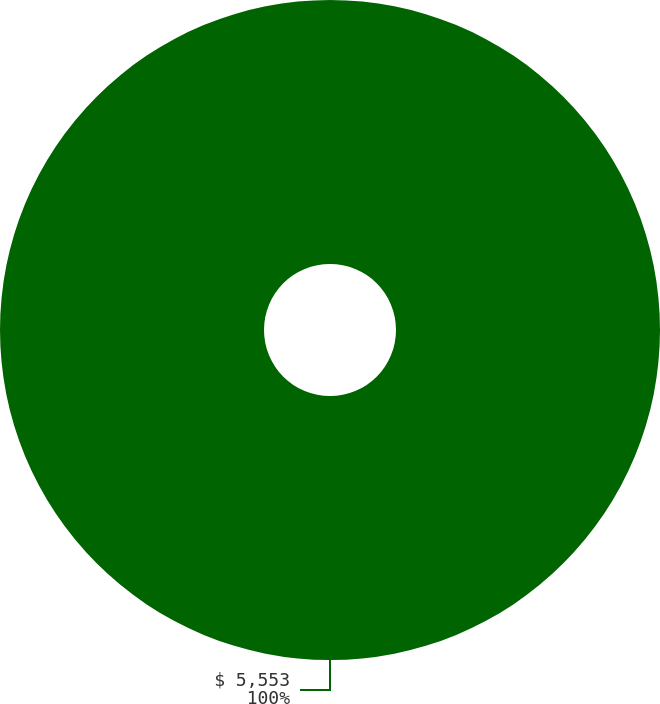Convert chart to OTSL. <chart><loc_0><loc_0><loc_500><loc_500><pie_chart><fcel>$ 5,553<nl><fcel>100.0%<nl></chart> 